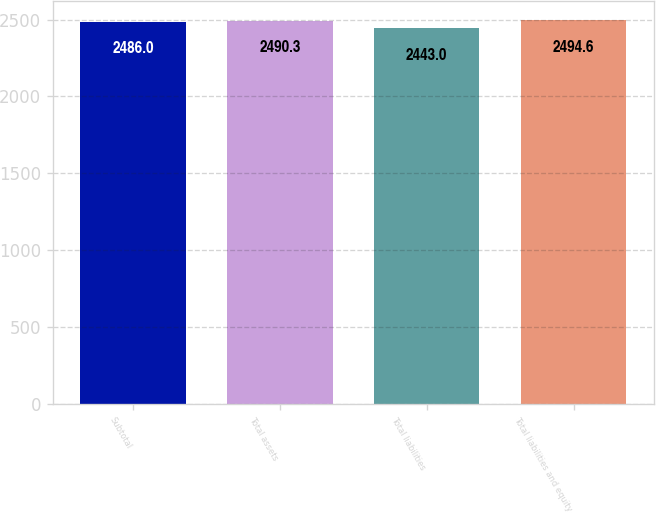Convert chart. <chart><loc_0><loc_0><loc_500><loc_500><bar_chart><fcel>Subtotal<fcel>Total assets<fcel>Total liabilities<fcel>Total liabilities and equity<nl><fcel>2486<fcel>2490.3<fcel>2443<fcel>2494.6<nl></chart> 